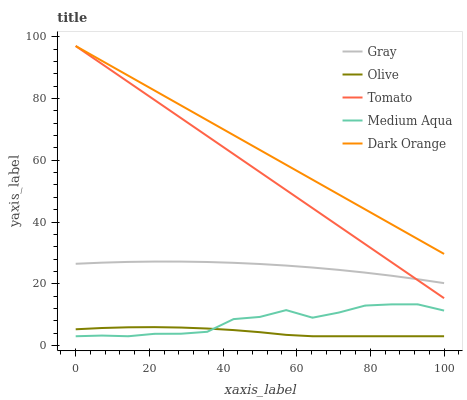Does Olive have the minimum area under the curve?
Answer yes or no. Yes. Does Dark Orange have the maximum area under the curve?
Answer yes or no. Yes. Does Gray have the minimum area under the curve?
Answer yes or no. No. Does Gray have the maximum area under the curve?
Answer yes or no. No. Is Dark Orange the smoothest?
Answer yes or no. Yes. Is Medium Aqua the roughest?
Answer yes or no. Yes. Is Gray the smoothest?
Answer yes or no. No. Is Gray the roughest?
Answer yes or no. No. Does Olive have the lowest value?
Answer yes or no. Yes. Does Gray have the lowest value?
Answer yes or no. No. Does Dark Orange have the highest value?
Answer yes or no. Yes. Does Gray have the highest value?
Answer yes or no. No. Is Olive less than Tomato?
Answer yes or no. Yes. Is Dark Orange greater than Olive?
Answer yes or no. Yes. Does Medium Aqua intersect Olive?
Answer yes or no. Yes. Is Medium Aqua less than Olive?
Answer yes or no. No. Is Medium Aqua greater than Olive?
Answer yes or no. No. Does Olive intersect Tomato?
Answer yes or no. No. 